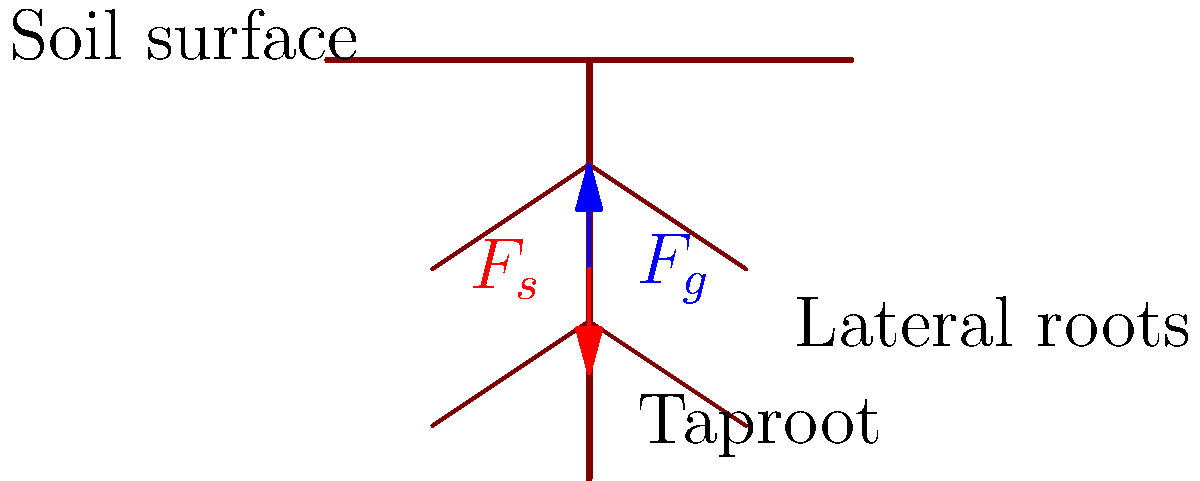In the simplified underground view of a desert plant's root system, what biomechanical advantage does the lateral root structure provide in relation to the forces $F_g$ (gravitational pull) and $F_s$ (soil resistance)? To understand the biomechanical advantage of the lateral root structure in desert plants, let's analyze the diagram step-by-step:

1. Root system structure:
   - The plant has a deep taproot extending vertically into the soil.
   - Lateral roots branch out horizontally from the taproot at different depths.

2. Forces acting on the root system:
   - $F_g$: Gravitational force pulling the plant downward
   - $F_s$: Soil resistance force pushing upward

3. Biomechanical advantages of lateral roots:

   a) Increased surface area:
      - Lateral roots significantly increase the total surface area of the root system.
      - This allows for greater water and nutrient absorption, crucial in desert environments.

   b) Improved anchorage:
      - Lateral roots spread horizontally, creating a wider base of support.
      - This distribution of roots helps counteract the downward pull of gravity ($F_g$).

   c) Enhanced soil interaction:
      - The lateral roots increase the contact area with the soil.
      - This amplifies the soil resistance force ($F_s$), providing better stability.

   d) Stress distribution:
      - Lateral roots help distribute the forces acting on the plant over a larger area.
      - This reduces the stress concentration on any single point of the root system.

   e) Adaptive growth:
      - Lateral roots can grow towards areas with higher water or nutrient content.
      - This allows the plant to efficiently utilize limited resources in desert soils.

4. Balance of forces:
   - The combination of the taproot and lateral roots creates a balance between $F_g$ and $F_s$.
   - This balance provides optimal stability and resource acquisition for the plant in harsh desert conditions.

In conclusion, the lateral root structure provides a biomechanical advantage by improving anchorage, increasing surface area for resource absorption, and enhancing the plant's ability to withstand environmental stresses in desert ecosystems.
Answer: Improved anchorage and increased surface area for resource absorption 